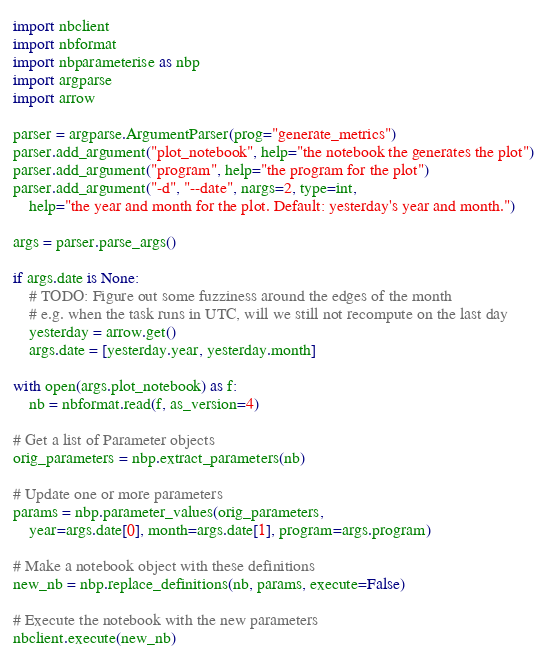Convert code to text. <code><loc_0><loc_0><loc_500><loc_500><_Python_>import nbclient
import nbformat
import nbparameterise as nbp
import argparse
import arrow

parser = argparse.ArgumentParser(prog="generate_metrics")
parser.add_argument("plot_notebook", help="the notebook the generates the plot")
parser.add_argument("program", help="the program for the plot")
parser.add_argument("-d", "--date", nargs=2, type=int,
    help="the year and month for the plot. Default: yesterday's year and month.")

args = parser.parse_args()

if args.date is None:
    # TODO: Figure out some fuzziness around the edges of the month
    # e.g. when the task runs in UTC, will we still not recompute on the last day
    yesterday = arrow.get()
    args.date = [yesterday.year, yesterday.month]

with open(args.plot_notebook) as f:
    nb = nbformat.read(f, as_version=4)

# Get a list of Parameter objects
orig_parameters = nbp.extract_parameters(nb)

# Update one or more parameters
params = nbp.parameter_values(orig_parameters,
    year=args.date[0], month=args.date[1], program=args.program)

# Make a notebook object with these definitions
new_nb = nbp.replace_definitions(nb, params, execute=False)

# Execute the notebook with the new parameters
nbclient.execute(new_nb)
</code> 